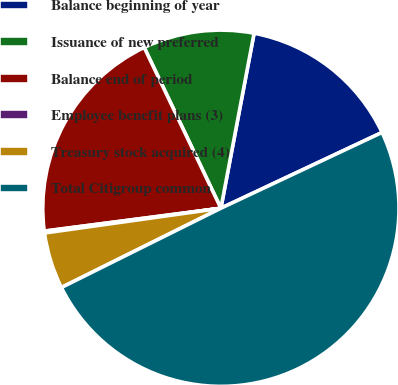Convert chart. <chart><loc_0><loc_0><loc_500><loc_500><pie_chart><fcel>Balance beginning of year<fcel>Issuance of new preferred<fcel>Balance end of period<fcel>Employee benefit plans (3)<fcel>Treasury stock acquired (4)<fcel>Total Citigroup common<nl><fcel>15.02%<fcel>10.07%<fcel>19.97%<fcel>0.17%<fcel>5.12%<fcel>49.66%<nl></chart> 